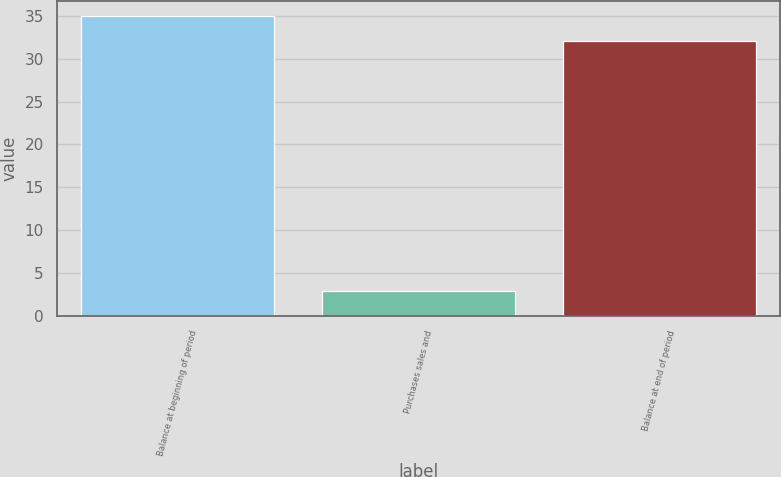Convert chart to OTSL. <chart><loc_0><loc_0><loc_500><loc_500><bar_chart><fcel>Balance at beginning of period<fcel>Purchases sales and<fcel>Balance at end of period<nl><fcel>35<fcel>3<fcel>32<nl></chart> 